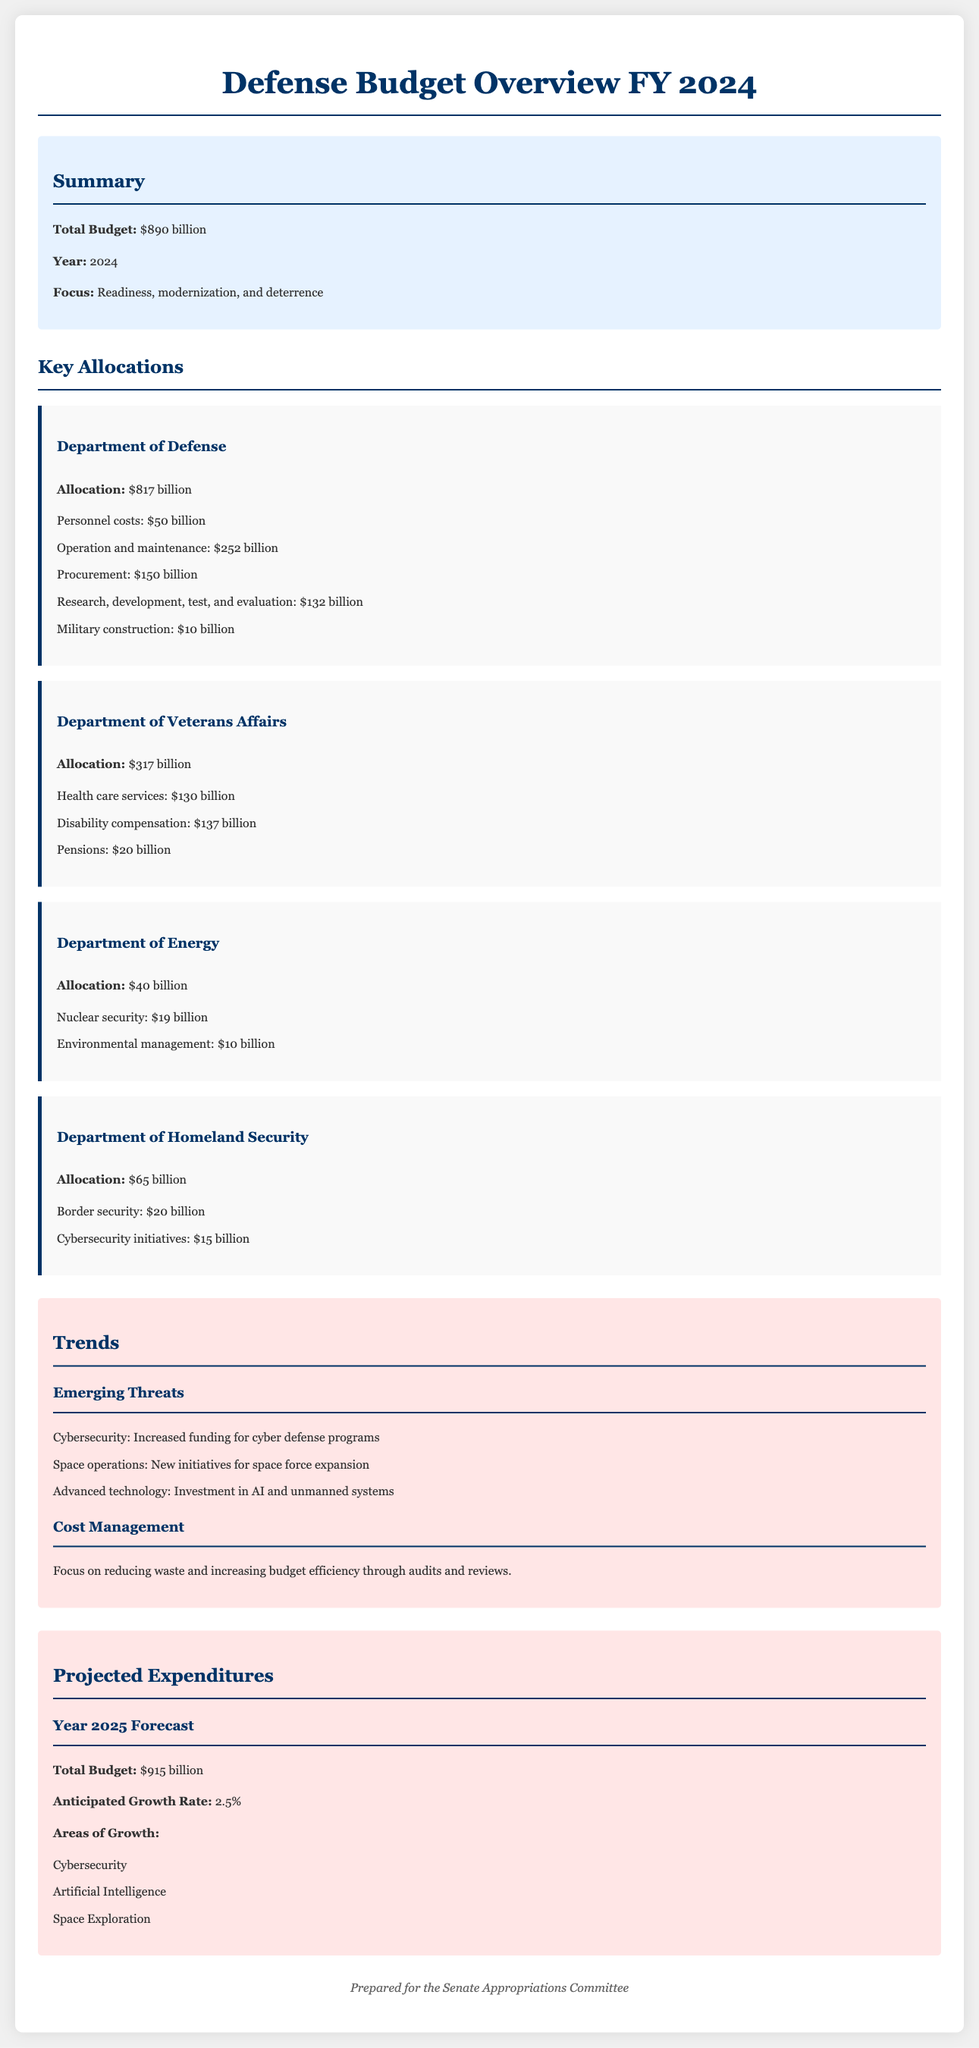what is the total defense budget for fiscal year 2024? The total defense budget mentioned in the document is stated directly under the summary section.
Answer: $890 billion how much of the budget is allocated to the Department of Defense? The allocation for the Department of Defense is specified in the key allocations section of the document.
Answer: $817 billion what is the allocation for health care services under the Department of Veterans Affairs? The allocation for health care services is detailed under the Department of Veterans Affairs section.
Answer: $130 billion what is one of the areas of growth projected for the year 2025? The document lists areas of growth for the forecast year, among which is specifically named.
Answer: Cybersecurity what is the anticipated growth rate for the defense budget in 2025? This is found under the projected expenditures section, listing the growth rate for the upcoming fiscal year.
Answer: 2.5% which department has the smallest allocation in the document? By comparing all department allocations in the key sections, this can be directly identified.
Answer: Department of Energy why is there an increase in funding for cybersecurity? The document links increased funding to the emerging threats highlighted in the trends section.
Answer: Emerging threats what is the focus area of the defense budget for fiscal year 2024? The focus of budget allocations is summarized in the document's overview section.
Answer: Readiness, modernization, and deterrence what is the total allocation for the Department of Homeland Security? The total allocation is specified in the key allocations section related to the respective department.
Answer: $65 billion 